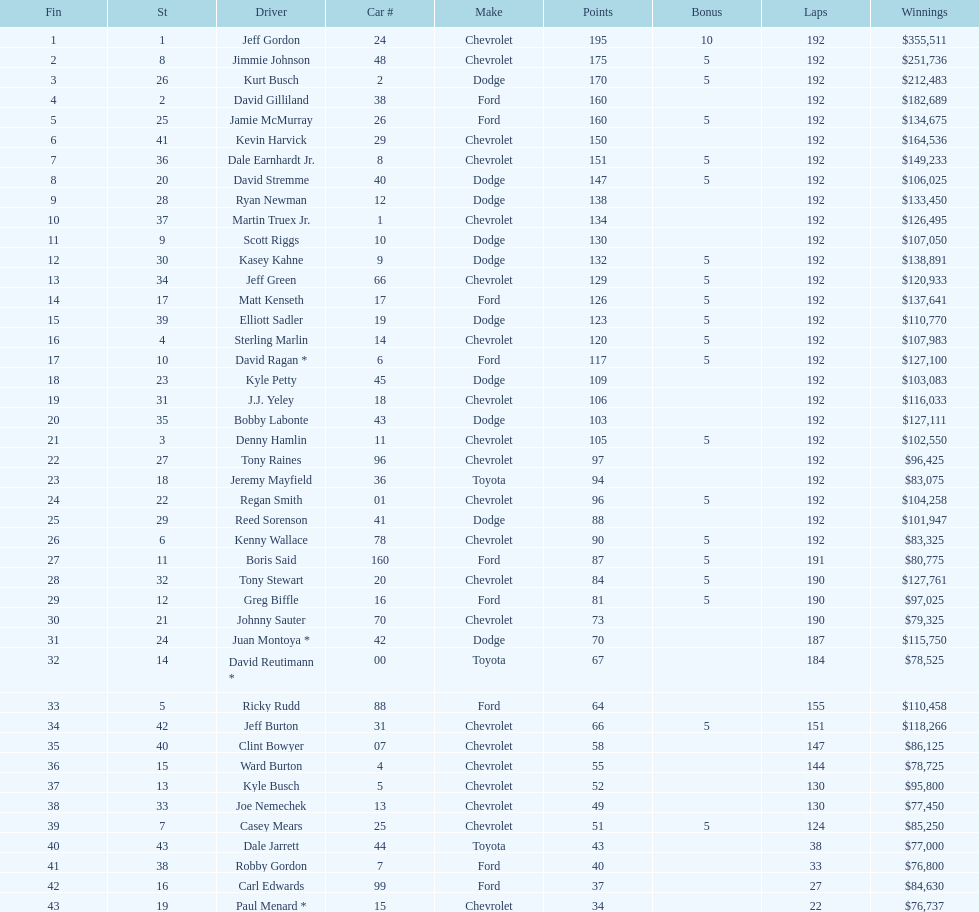How many racers finished below tony stewart? 15. 